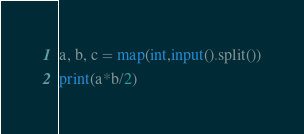<code> <loc_0><loc_0><loc_500><loc_500><_Python_>a, b, c = map(int,input().split())
print(a*b/2)</code> 